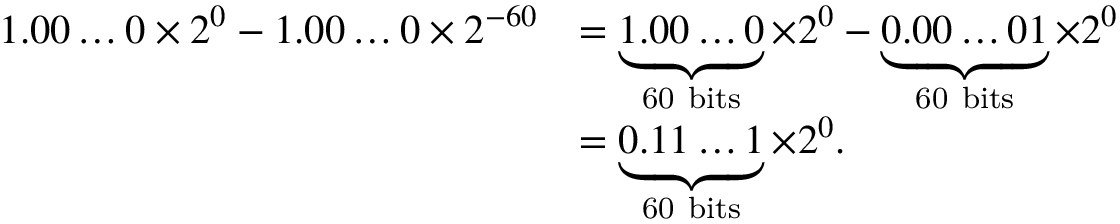Convert formula to latex. <formula><loc_0><loc_0><loc_500><loc_500>{ \begin{array} { r l } { 1 . 0 0 \dots 0 \times 2 ^ { 0 } - 1 . 0 0 \dots 0 \times 2 ^ { - 6 0 } } & { = \underbrace { 1 . 0 0 \dots 0 } _ { 6 0 b i t s } \times 2 ^ { 0 } - \underbrace { 0 . 0 0 \dots 0 1 } _ { 6 0 b i t s } \times 2 ^ { 0 } } \\ & { = \underbrace { 0 . 1 1 \dots 1 } _ { 6 0 b i t s } \times 2 ^ { 0 } . } \end{array} }</formula> 